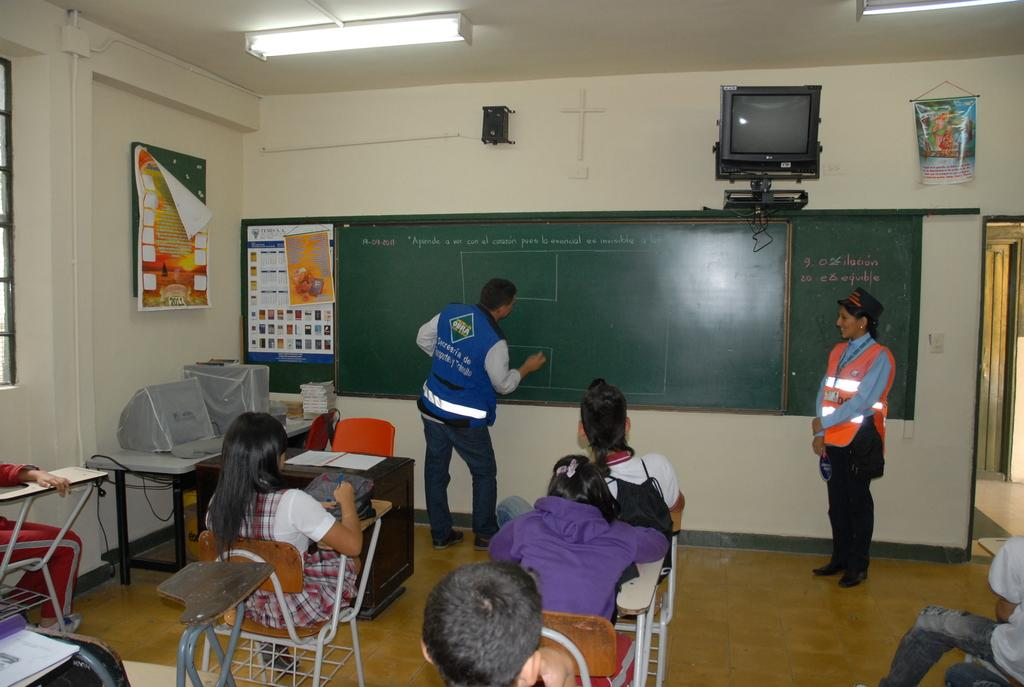How many people are in the image? There are people in the image, but the exact number is not specified. What are the positions of the people in the image? Two of the people are standing, and the rest are sitting on chairs. What can be seen in the background of the image? There is a television, a speaker, and posters in the background of the image. What type of stamp can be seen on the apple in the image? There is no apple or stamp present in the image. How many cattle are visible in the image? There are no cattle present in the image. 